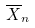Convert formula to latex. <formula><loc_0><loc_0><loc_500><loc_500>\overline { X } _ { n }</formula> 